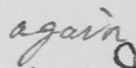Transcribe the text shown in this historical manuscript line. again 